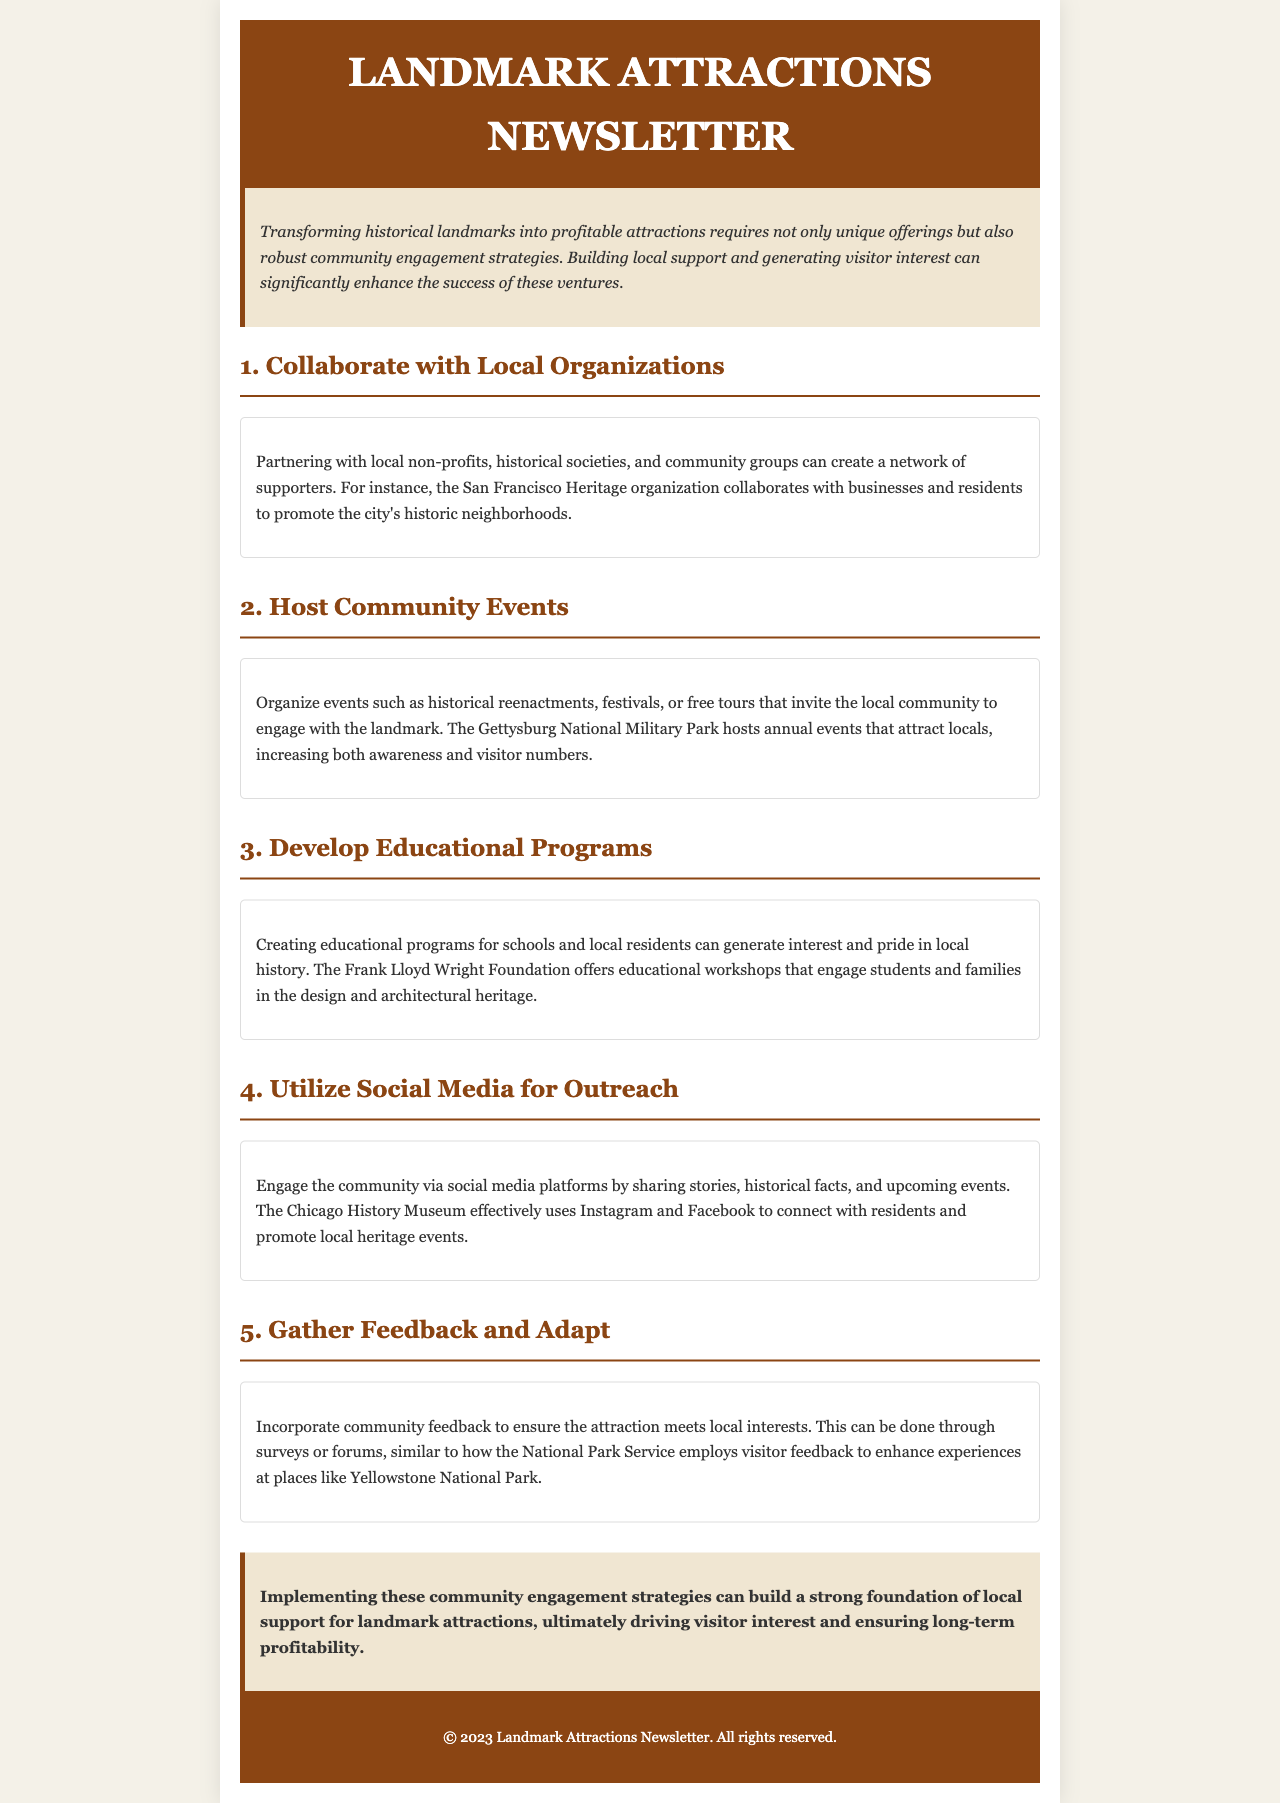What is the title of the newsletter? The title appears in the header section of the document, which is "Landmark Attractions Newsletter."
Answer: Landmark Attractions Newsletter Who collaborates with local businesses and residents in San Francisco? This information is mentioned in the section about collaborating with local organizations, indicating "San Francisco Heritage organization."
Answer: San Francisco Heritage organization What type of events are suggested to engage the local community? The document suggests "historical reenactments, festivals, or free tours" in the section on hosting community events.
Answer: historical reenactments, festivals, or free tours Which organization offers educational workshops related to design and architectural heritage? The section about educational programs mentions "the Frank Lloyd Wright Foundation" providing educational workshops.
Answer: the Frank Lloyd Wright Foundation What social media platforms are mentioned for community engagement? The document specifies "Instagram and Facebook" in the section on utilizing social media for outreach.
Answer: Instagram and Facebook How should feedback be gathered from the community? The document notes that community feedback can be gathered through "surveys or forums" in the section discussing feedback.
Answer: surveys or forums What is the main purpose of implementing community engagement strategies? According to the conclusion, the main purpose is to "build a strong foundation of local support for landmark attractions."
Answer: build a strong foundation of local support for landmark attractions What background color is used for the section titles? The document describes the section titles having a background color of "#f0e6d2."
Answer: #f0e6d2 